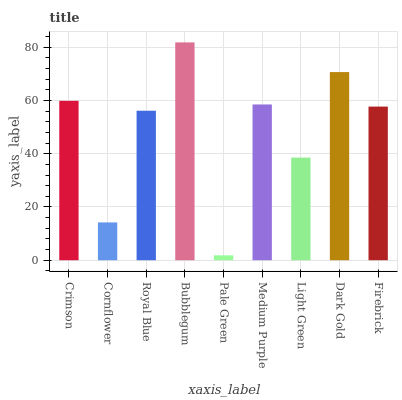Is Cornflower the minimum?
Answer yes or no. No. Is Cornflower the maximum?
Answer yes or no. No. Is Crimson greater than Cornflower?
Answer yes or no. Yes. Is Cornflower less than Crimson?
Answer yes or no. Yes. Is Cornflower greater than Crimson?
Answer yes or no. No. Is Crimson less than Cornflower?
Answer yes or no. No. Is Firebrick the high median?
Answer yes or no. Yes. Is Firebrick the low median?
Answer yes or no. Yes. Is Royal Blue the high median?
Answer yes or no. No. Is Pale Green the low median?
Answer yes or no. No. 